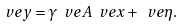<formula> <loc_0><loc_0><loc_500><loc_500>\ v e { y } = \gamma \ v e { A } \ v e { x } + \ v e { \eta } .</formula> 